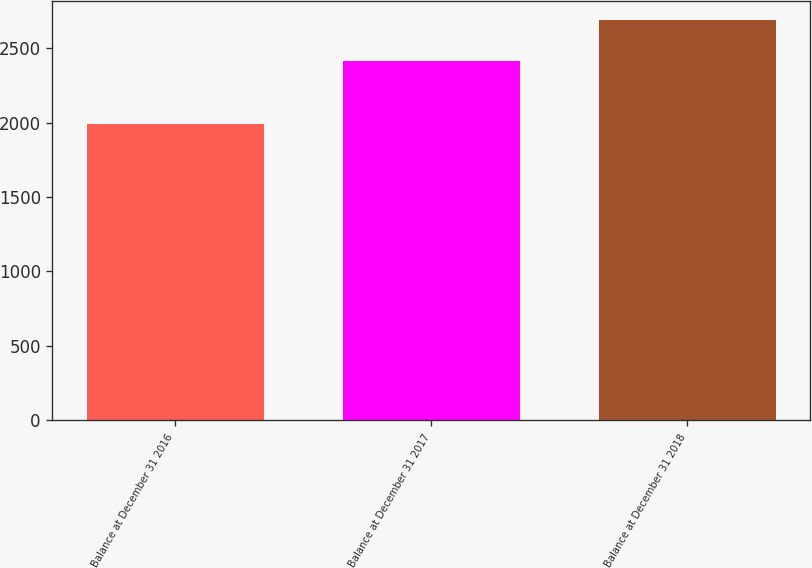<chart> <loc_0><loc_0><loc_500><loc_500><bar_chart><fcel>Balance at December 31 2016<fcel>Balance at December 31 2017<fcel>Balance at December 31 2018<nl><fcel>1992.7<fcel>2411.4<fcel>2685.7<nl></chart> 